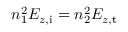Convert formula to latex. <formula><loc_0><loc_0><loc_500><loc_500>n _ { 1 } ^ { 2 } E _ { z , i } = n _ { 2 } ^ { 2 } E _ { z , t }</formula> 